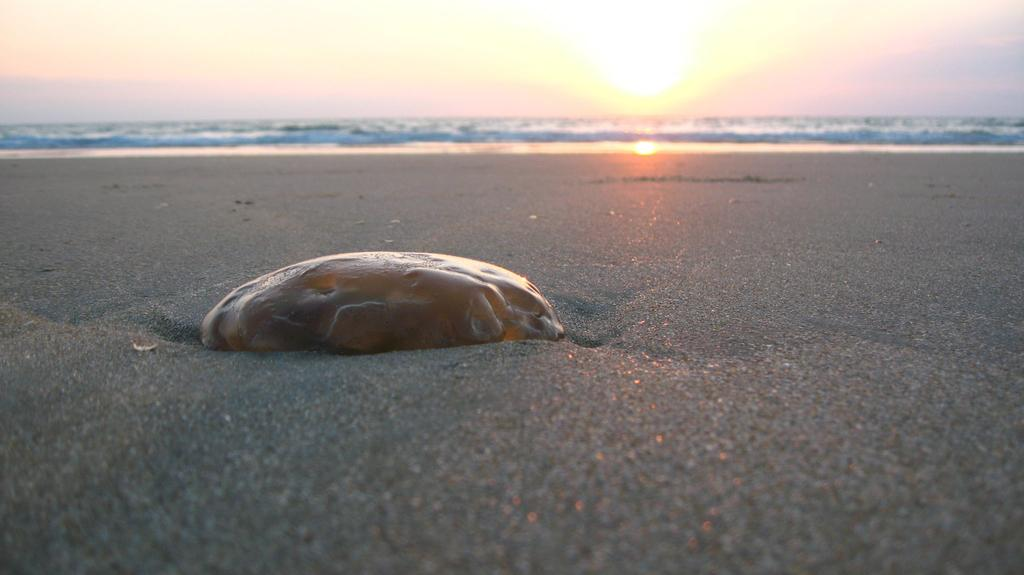What is the main subject of the image? There is an object on the sand in the image. Can you describe the setting of the image? The setting of the image includes sand and water visible in the background. What type of sound can be heard coming from the object in the image? There is no sound present in the image, as it is a still image and not a video or audio recording. 